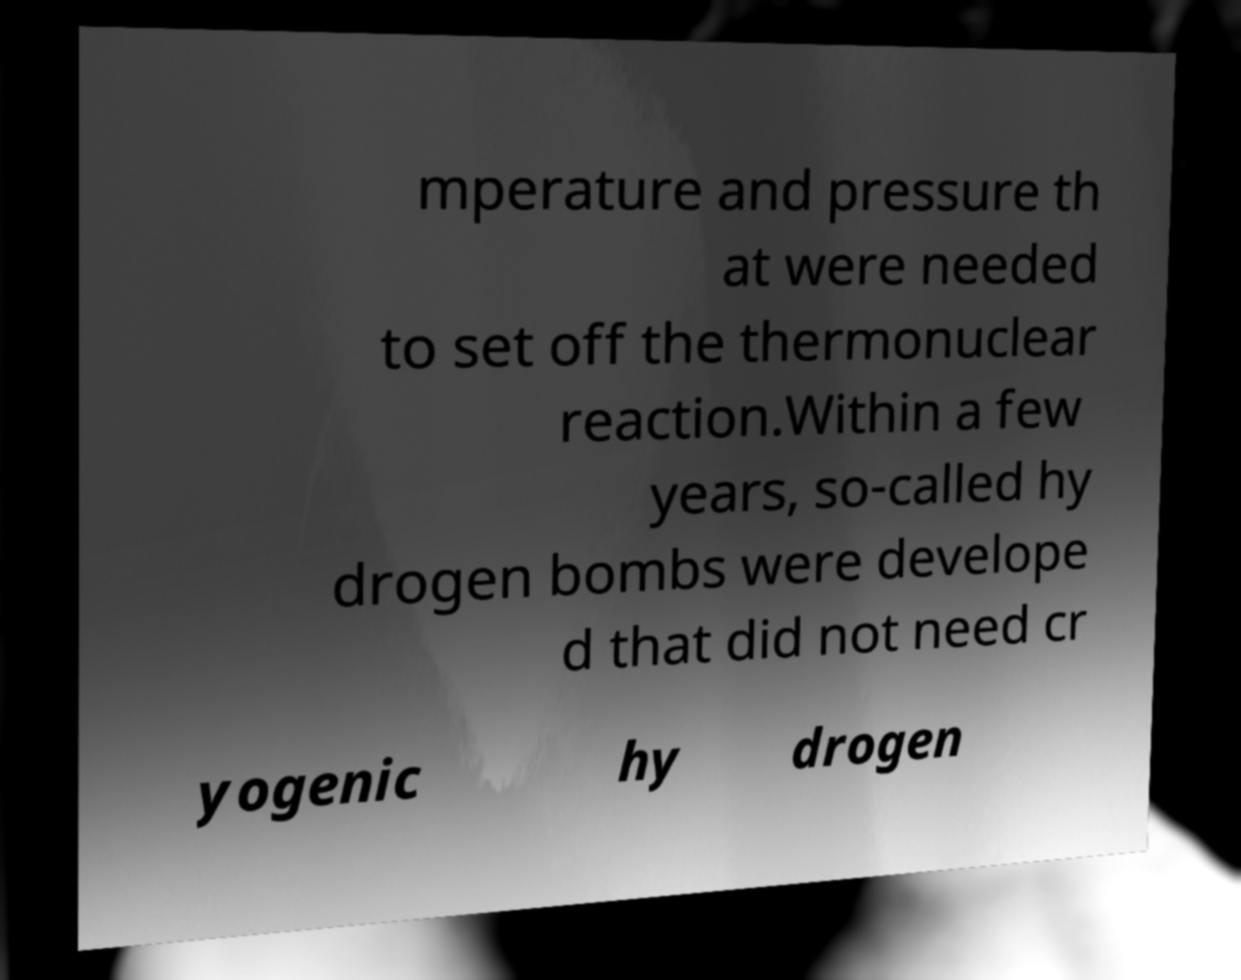Please read and relay the text visible in this image. What does it say? mperature and pressure th at were needed to set off the thermonuclear reaction.Within a few years, so-called hy drogen bombs were develope d that did not need cr yogenic hy drogen 